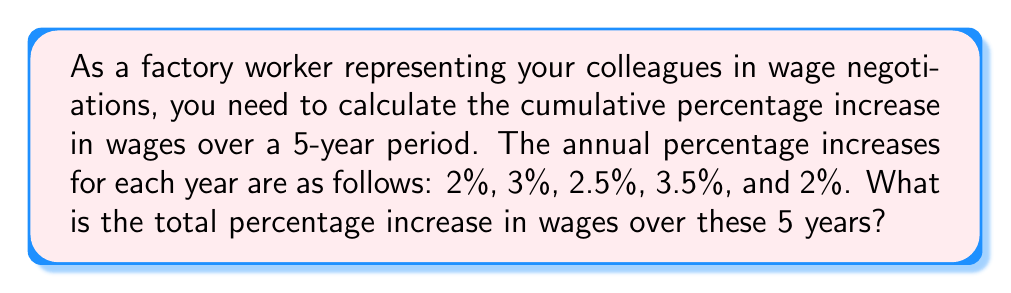Solve this math problem. To solve this problem, we need to understand that percentage increases compound over time. We can't simply add the percentages together. Instead, we need to calculate the cumulative effect of these increases.

Let's approach this step-by-step:

1) First, let's convert each percentage increase to a decimal:
   2% = 0.02, 3% = 0.03, 2.5% = 0.025, 3.5% = 0.035, 2% = 0.02

2) Now, for each year, we need to calculate the factor by which the wage increases:
   Year 1: 1 + 0.02 = 1.02
   Year 2: 1 + 0.03 = 1.03
   Year 3: 1 + 0.025 = 1.025
   Year 4: 1 + 0.035 = 1.035
   Year 5: 1 + 0.02 = 1.02

3) To get the cumulative effect, we multiply these factors:

   $$ 1.02 \times 1.03 \times 1.025 \times 1.035 \times 1.02 = 1.136605625 $$

4) This result means that after 5 years, the wage will be 1.136605625 times the original wage.

5) To convert this to a percentage increase, we subtract 1 and multiply by 100:

   $$ (1.136605625 - 1) \times 100 = 0.136605625 \times 100 = 13.6605625\% $$

Therefore, the total percentage increase in wages over these 5 years is approximately 13.66%.
Answer: The total percentage increase in wages over the 5-year period is approximately 13.66%. 